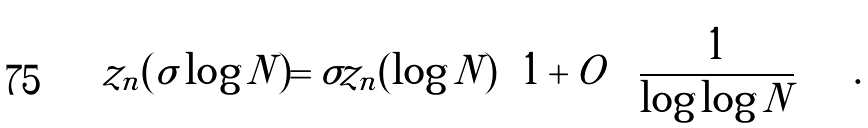Convert formula to latex. <formula><loc_0><loc_0><loc_500><loc_500>z _ { n } ( \sigma \log N ) = \sigma z _ { n } ( \log N ) \left ( 1 + O \left ( \frac { 1 } { \log \log N } \right ) \right ) \, .</formula> 